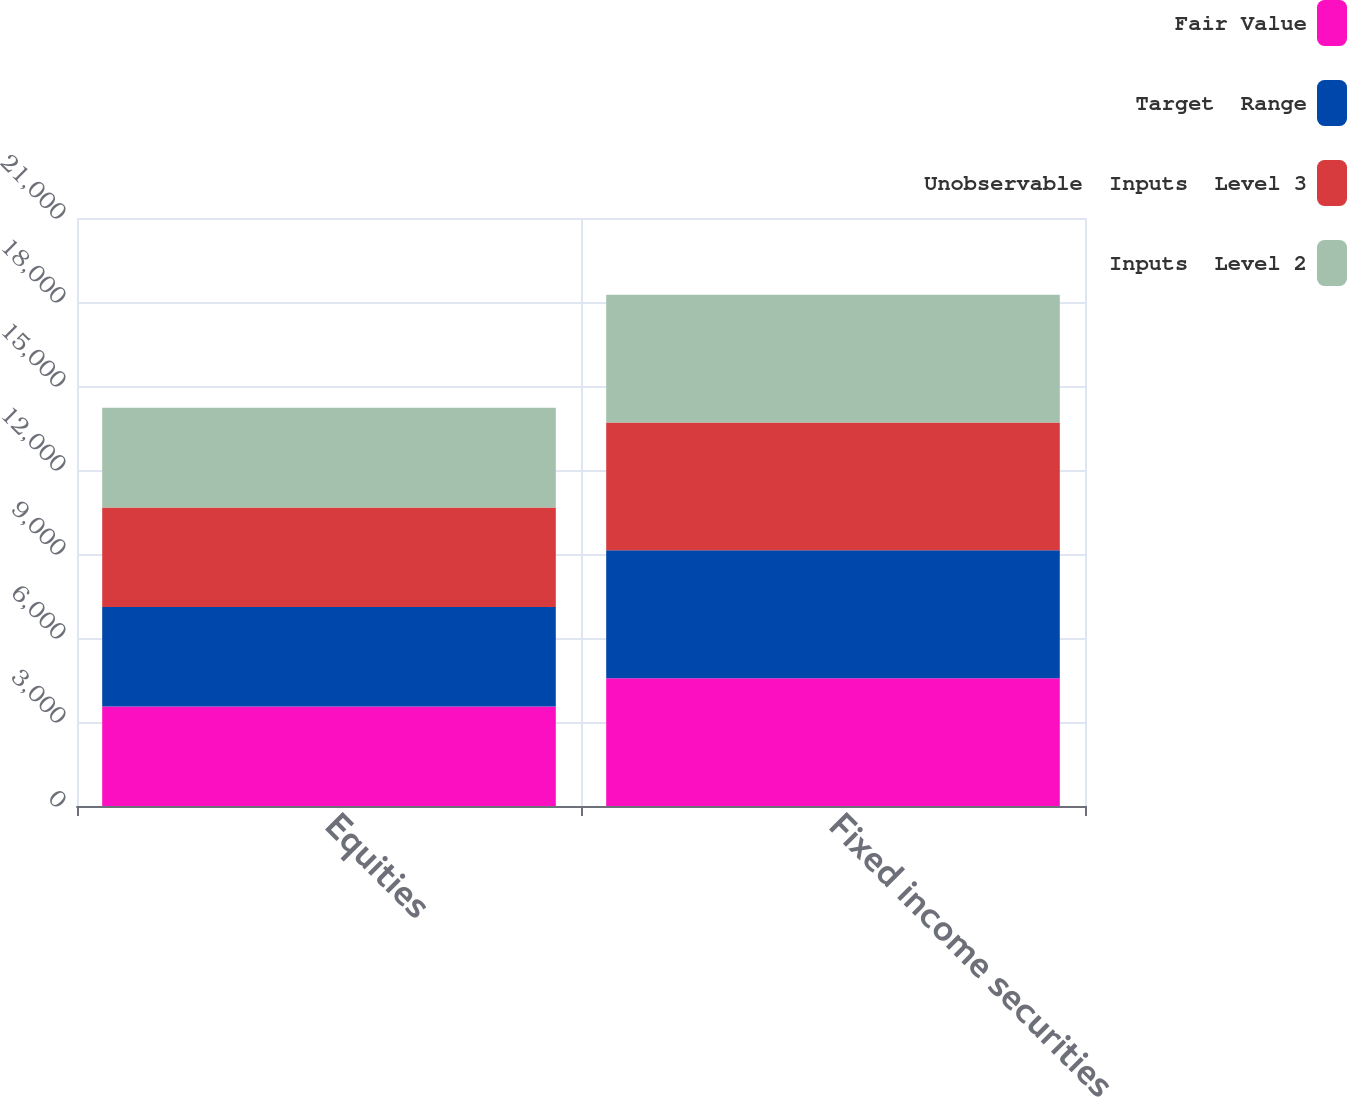<chart> <loc_0><loc_0><loc_500><loc_500><stacked_bar_chart><ecel><fcel>Equities<fcel>Fixed income securities<nl><fcel>Fair Value<fcel>3555<fcel>4565<nl><fcel>Target  Range<fcel>3555<fcel>4565<nl><fcel>Unobservable  Inputs  Level 3<fcel>3555<fcel>4565<nl><fcel>Inputs  Level 2<fcel>3555<fcel>4565<nl></chart> 